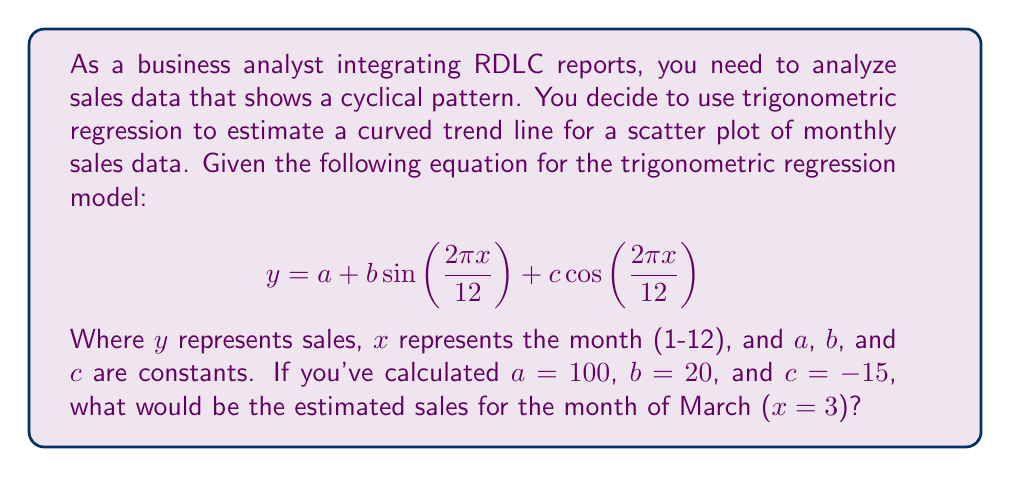Can you answer this question? To solve this problem, we'll follow these steps:

1. Identify the given values:
   $a = 100$, $b = 20$, $c = -15$, $x = 3$ (for March)

2. Substitute these values into the trigonometric regression equation:
   $$ y = 100 + 20 \sin(\frac{2\pi \cdot 3}{12}) + (-15) \cos(\frac{2\pi \cdot 3}{12}) $$

3. Simplify the arguments of sine and cosine:
   $$ y = 100 + 20 \sin(\frac{\pi}{2}) + (-15) \cos(\frac{\pi}{2}) $$

4. Calculate the sine and cosine values:
   $\sin(\frac{\pi}{2}) = 1$
   $\cos(\frac{\pi}{2}) = 0$

5. Substitute these values:
   $$ y = 100 + 20 \cdot 1 + (-15) \cdot 0 $$

6. Perform the calculations:
   $$ y = 100 + 20 + 0 = 120 $$

Therefore, the estimated sales for the month of March would be 120 units.
Answer: 120 units 